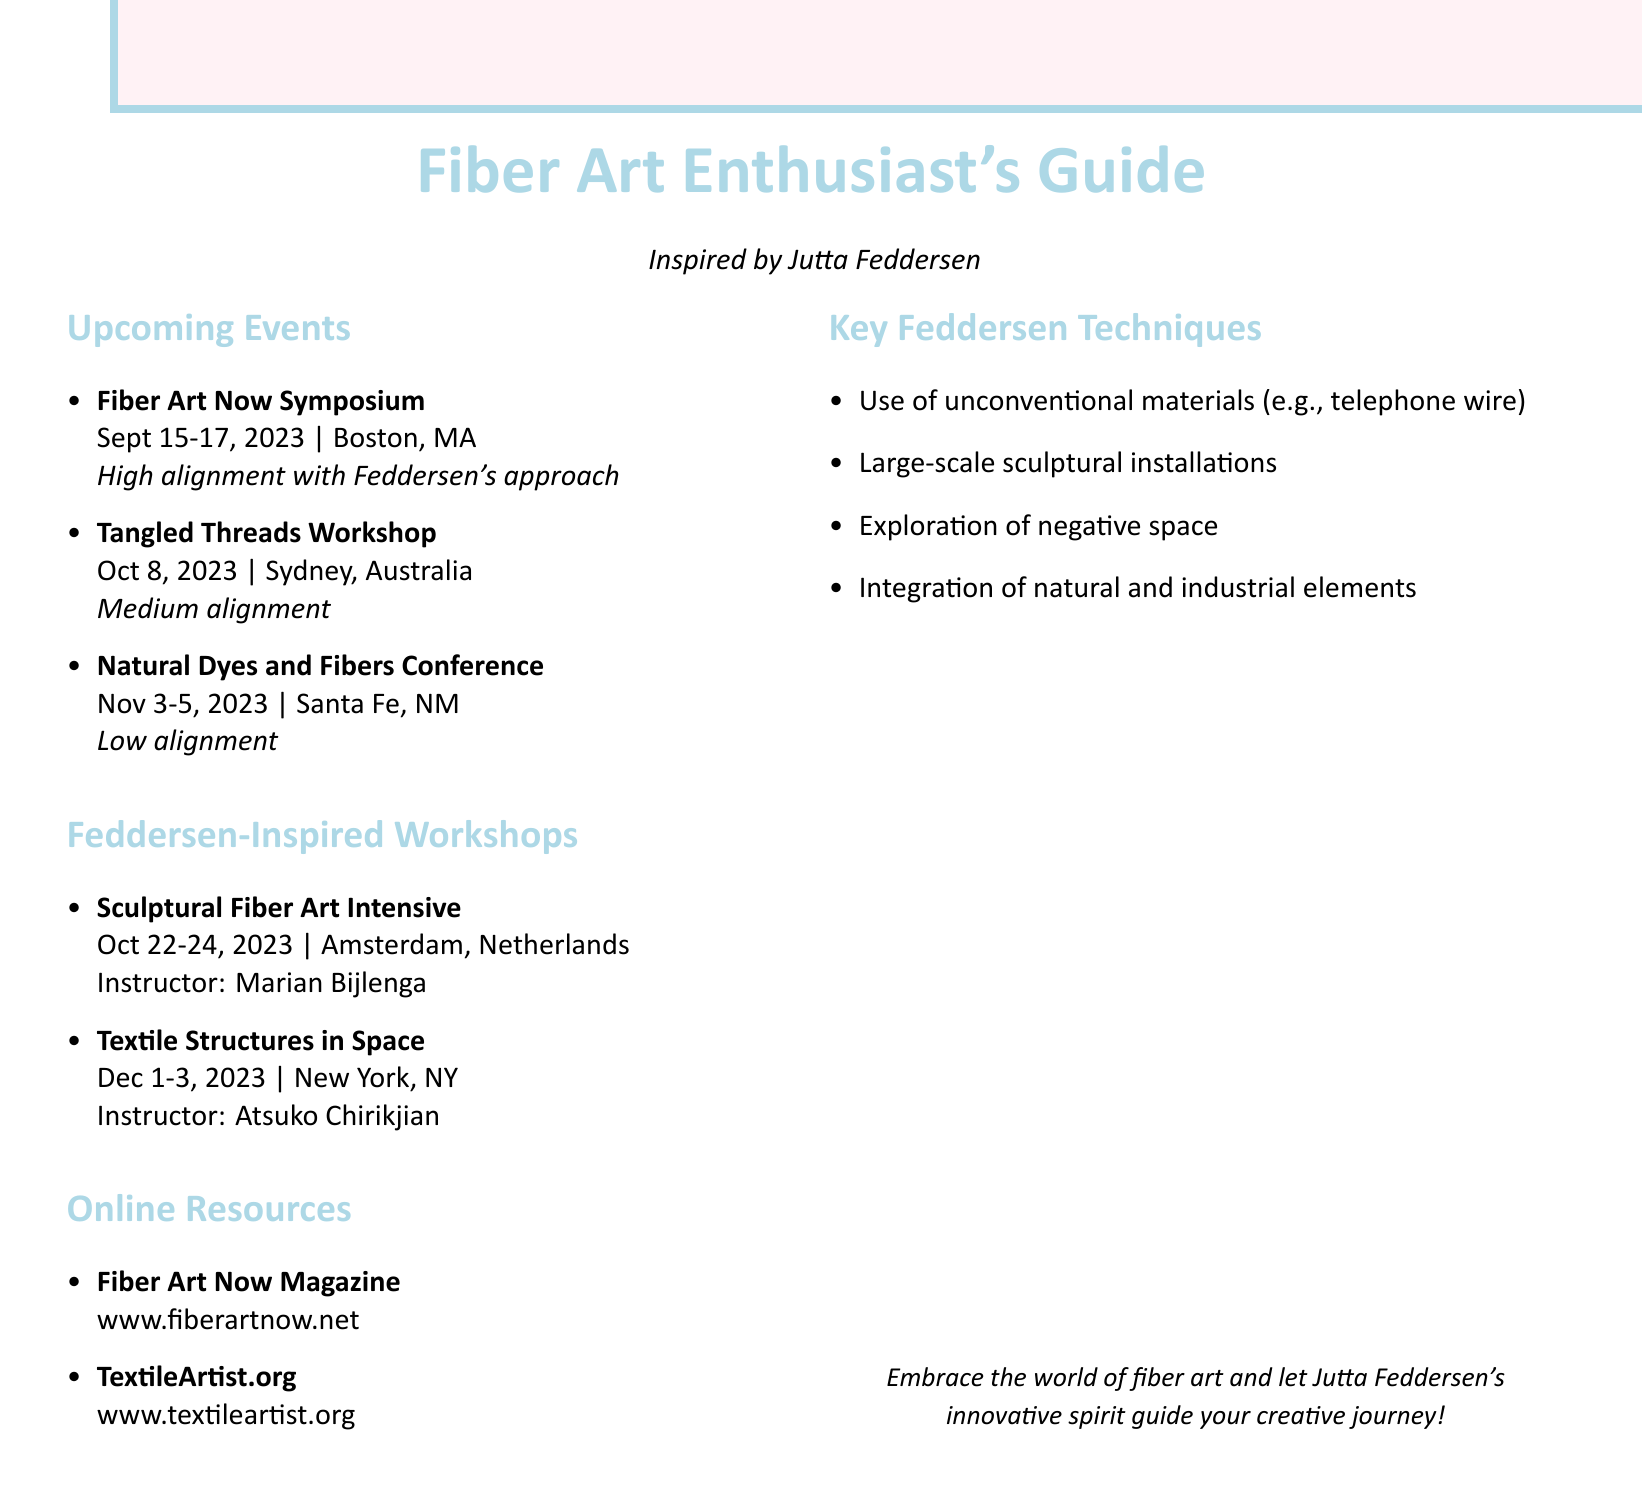What is the location of the Fiber Art Now Symposium? The location is specified in the document next to the event name.
Answer: Boston, MA What are the dates for the Tangled Threads Workshop? The dates are clearly stated in the workshop entry in the document.
Answer: October 8, 2023 Who is the instructor for the Sculptural Fiber Art Intensive? The instructor's name is mentioned beside the workshop description in the document.
Answer: Marian Bijlenga How many upcoming events are listed in the document? The total count of events is the sum of entries in the upcoming events section.
Answer: 3 What is the alignment level of the Natural Dyes and Fibers Conference with Feddersen's approach? The alignment level is provided in a specific note next to the conference details.
Answer: Low What is the description of the Textile Structures in Space workshop? The description is outlined in the entry for the workshop in the document.
Answer: Focuses on creating large-scale fiber installations, inspired by artists like Feddersen Name one online resource mentioned in the document. The document lists online resources that can be easily retrieved by their titles.
Answer: Fiber Art Now Magazine What is one of the key techniques used by Feddersen? The key techniques are listed in the document, providing concise information.
Answer: Use of unconventional materials (e.g., telephone wire) 